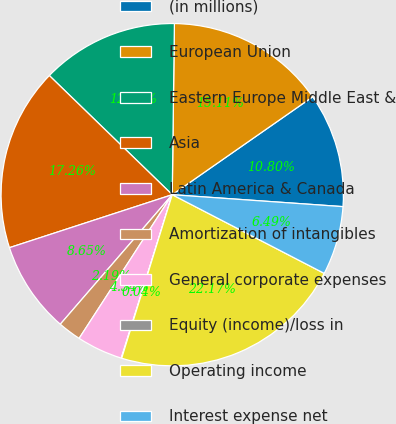Convert chart to OTSL. <chart><loc_0><loc_0><loc_500><loc_500><pie_chart><fcel>(in millions)<fcel>European Union<fcel>Eastern Europe Middle East &<fcel>Asia<fcel>Latin America & Canada<fcel>Amortization of intangibles<fcel>General corporate expenses<fcel>Equity (income)/loss in<fcel>Operating income<fcel>Interest expense net<nl><fcel>10.8%<fcel>15.11%<fcel>12.95%<fcel>17.26%<fcel>8.65%<fcel>2.19%<fcel>4.34%<fcel>0.04%<fcel>22.17%<fcel>6.49%<nl></chart> 